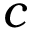Convert formula to latex. <formula><loc_0><loc_0><loc_500><loc_500>c</formula> 